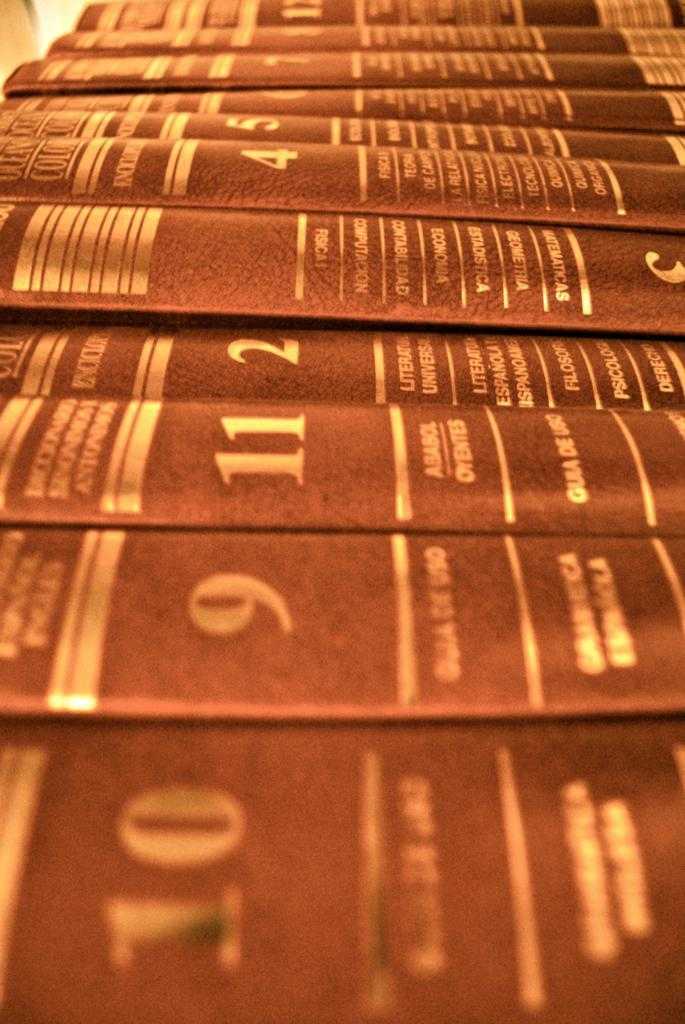<image>
Offer a succinct explanation of the picture presented. A close up of a row of reference books including volumes 10, 9, 11, 4 and several others. 